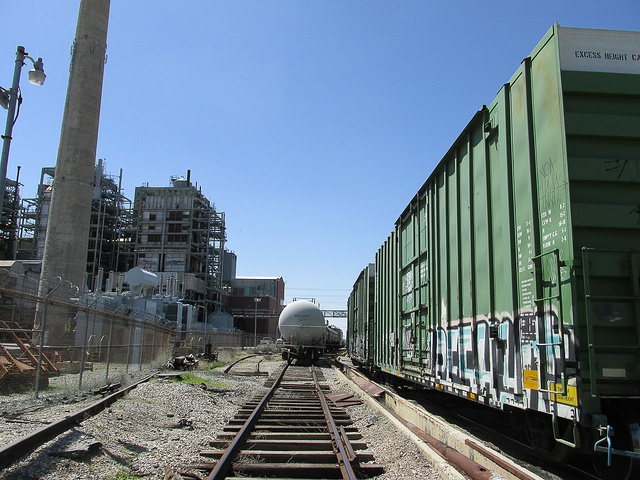Describe the objects in this image and their specific colors. I can see train in lightblue, black, darkgray, gray, and teal tones and train in lightblue, gray, black, lightgray, and darkgray tones in this image. 